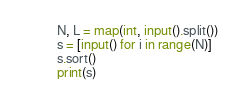<code> <loc_0><loc_0><loc_500><loc_500><_Python_>N, L = map(int, input().split())
s = [input() for i in range(N)]
s.sort()
print(s)
</code> 